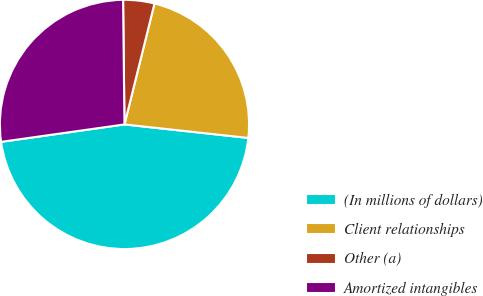<chart> <loc_0><loc_0><loc_500><loc_500><pie_chart><fcel>(In millions of dollars)<fcel>Client relationships<fcel>Other (a)<fcel>Amortized intangibles<nl><fcel>46.04%<fcel>22.86%<fcel>4.05%<fcel>27.06%<nl></chart> 